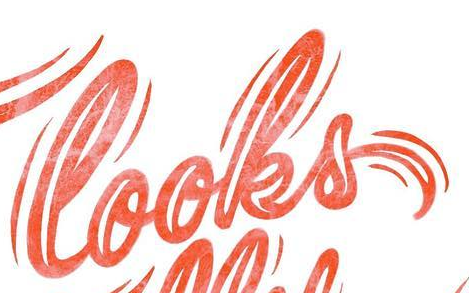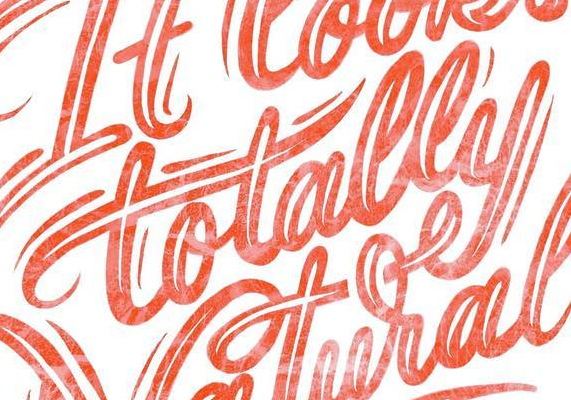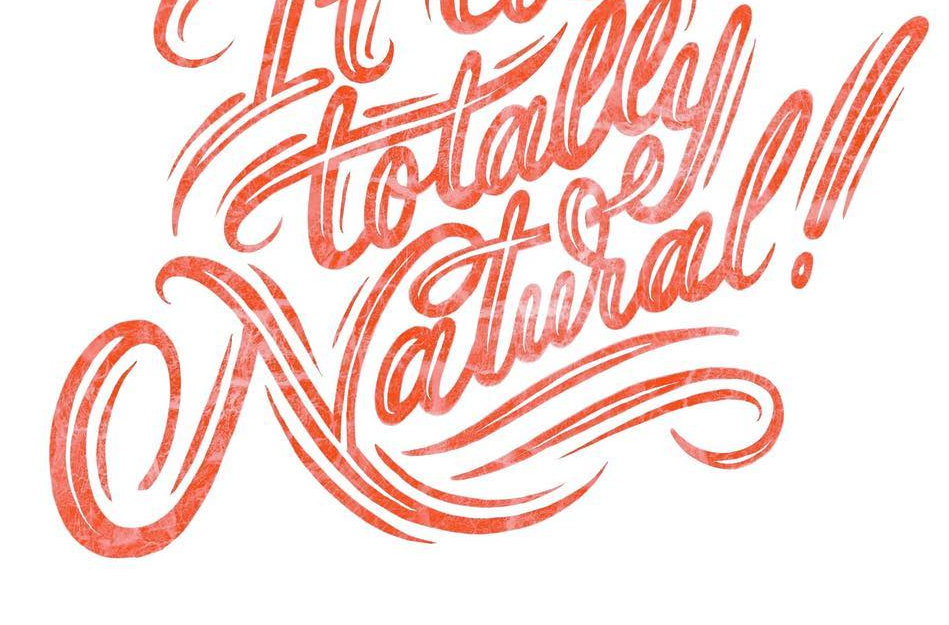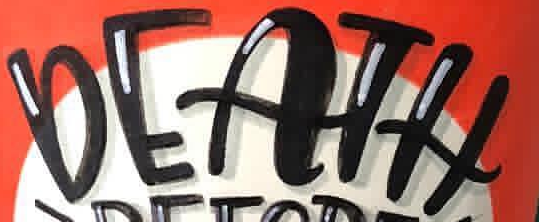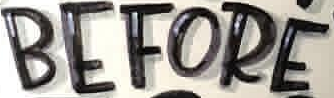Read the text content from these images in order, separated by a semicolon. looks; totally; Natural!; DEATH; BEFORE 